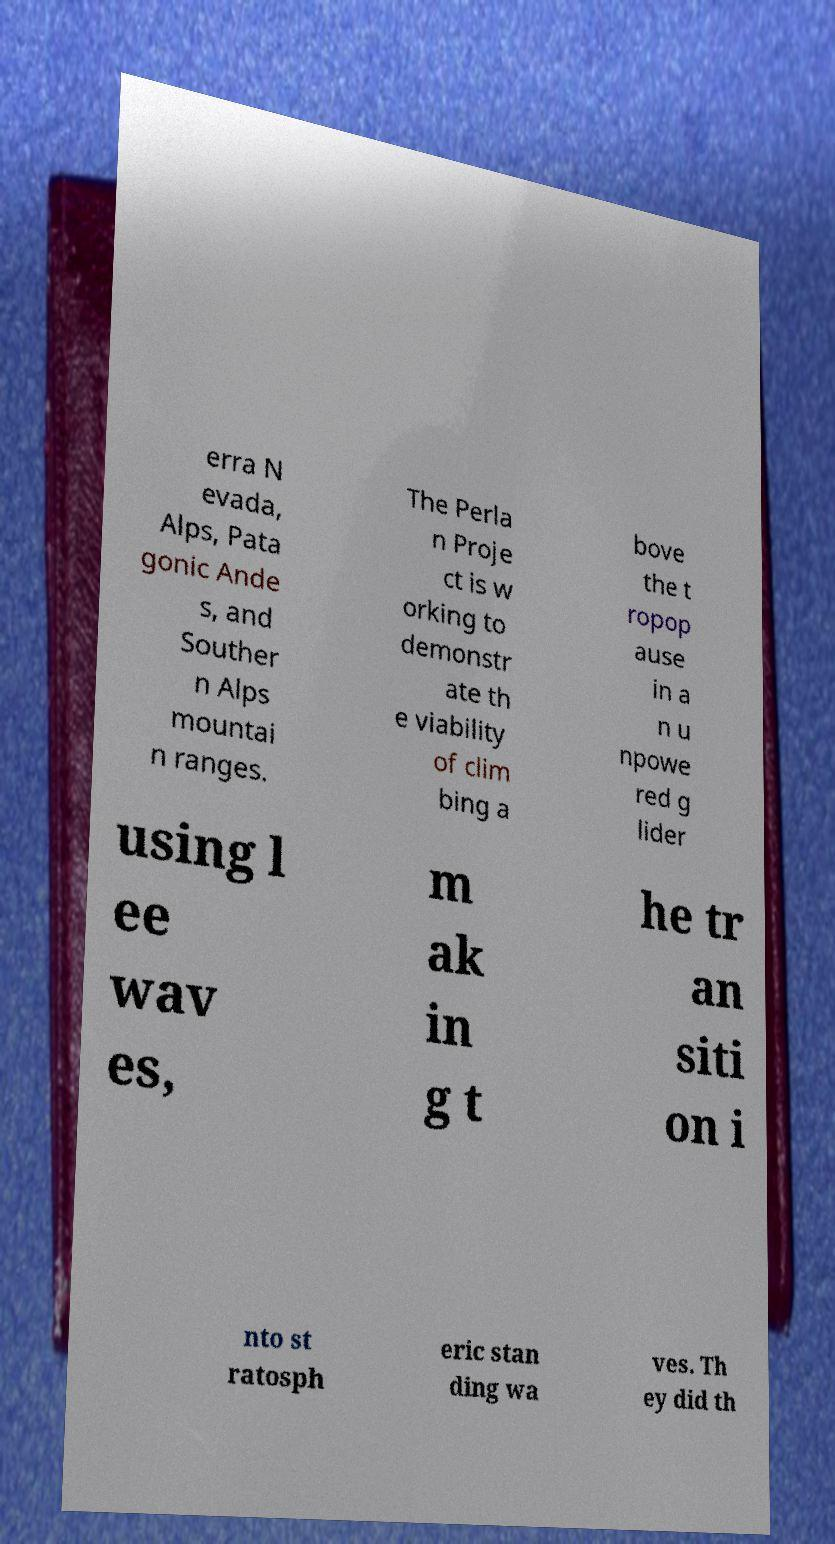Can you accurately transcribe the text from the provided image for me? erra N evada, Alps, Pata gonic Ande s, and Souther n Alps mountai n ranges. The Perla n Proje ct is w orking to demonstr ate th e viability of clim bing a bove the t ropop ause in a n u npowe red g lider using l ee wav es, m ak in g t he tr an siti on i nto st ratosph eric stan ding wa ves. Th ey did th 